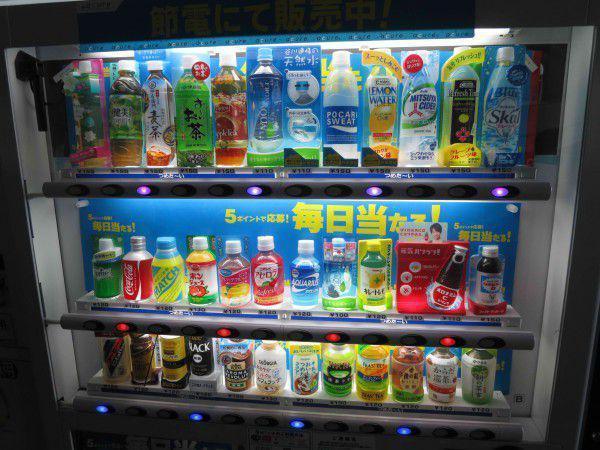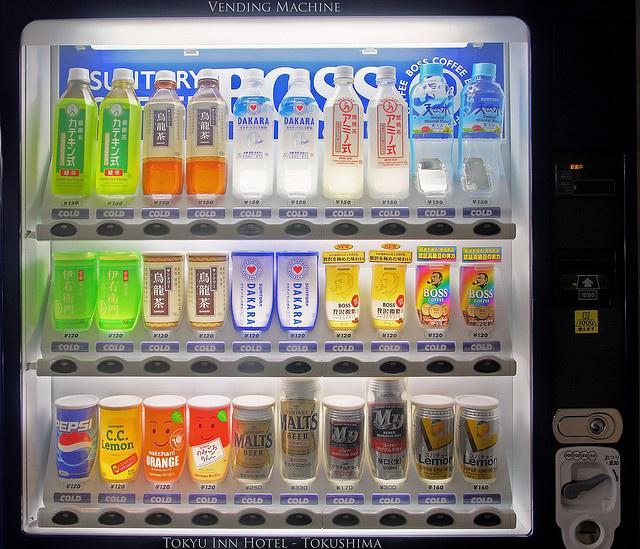The first image is the image on the left, the second image is the image on the right. Evaluate the accuracy of this statement regarding the images: "Only three shelves of items are visible in the vending machine in the image on the left". Is it true? Answer yes or no. Yes. The first image is the image on the left, the second image is the image on the right. Assess this claim about the two images: "A display has two identical green labeled drinks in the upper left corner.". Correct or not? Answer yes or no. Yes. 